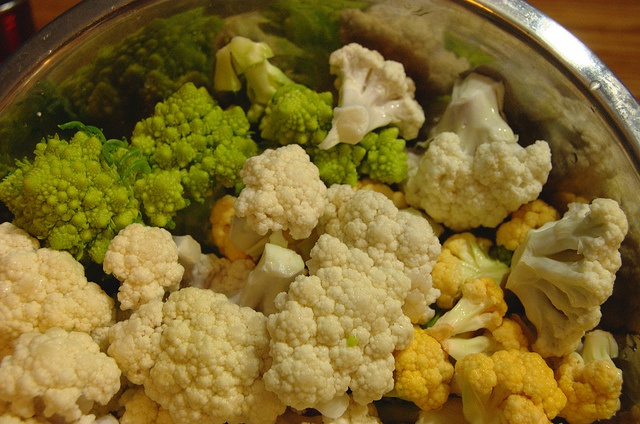Describe the objects in this image and their specific colors. I can see bowl in olive, tan, and black tones, broccoli in black and olive tones, broccoli in black, olive, and tan tones, broccoli in black and darkgreen tones, and broccoli in black, olive, and darkgreen tones in this image. 